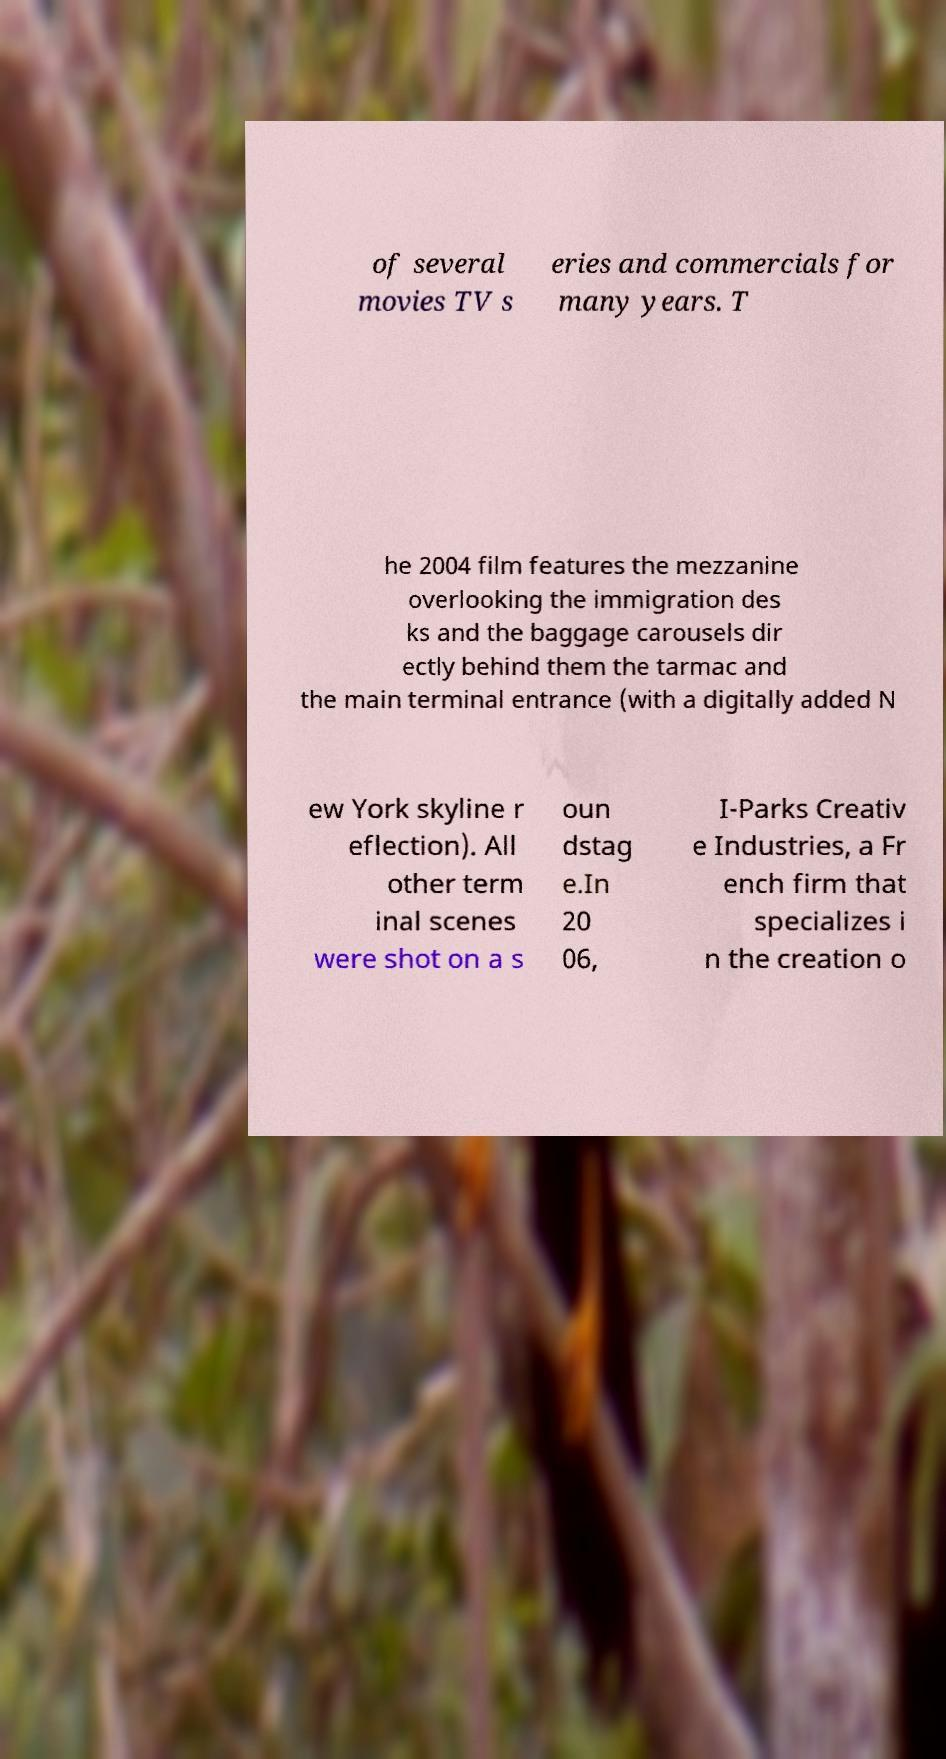What messages or text are displayed in this image? I need them in a readable, typed format. of several movies TV s eries and commercials for many years. T he 2004 film features the mezzanine overlooking the immigration des ks and the baggage carousels dir ectly behind them the tarmac and the main terminal entrance (with a digitally added N ew York skyline r eflection). All other term inal scenes were shot on a s oun dstag e.In 20 06, I-Parks Creativ e Industries, a Fr ench firm that specializes i n the creation o 